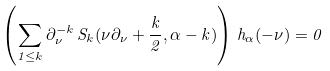<formula> <loc_0><loc_0><loc_500><loc_500>\left ( \sum _ { 1 \leq k } \partial _ { \nu } ^ { - k } \, S _ { k } ( \nu \partial _ { \nu } + \frac { k } { 2 } , \alpha - k ) \right ) \, h _ { \alpha } ( - \nu ) = 0</formula> 